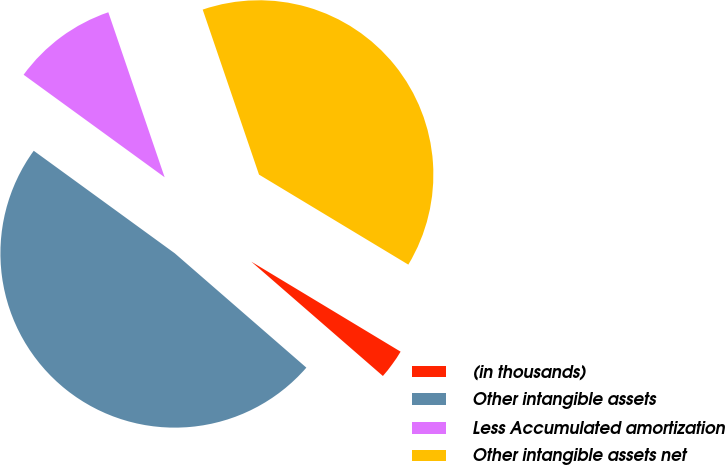Convert chart to OTSL. <chart><loc_0><loc_0><loc_500><loc_500><pie_chart><fcel>(in thousands)<fcel>Other intangible assets<fcel>Less Accumulated amortization<fcel>Other intangible assets net<nl><fcel>2.75%<fcel>48.62%<fcel>9.76%<fcel>38.87%<nl></chart> 